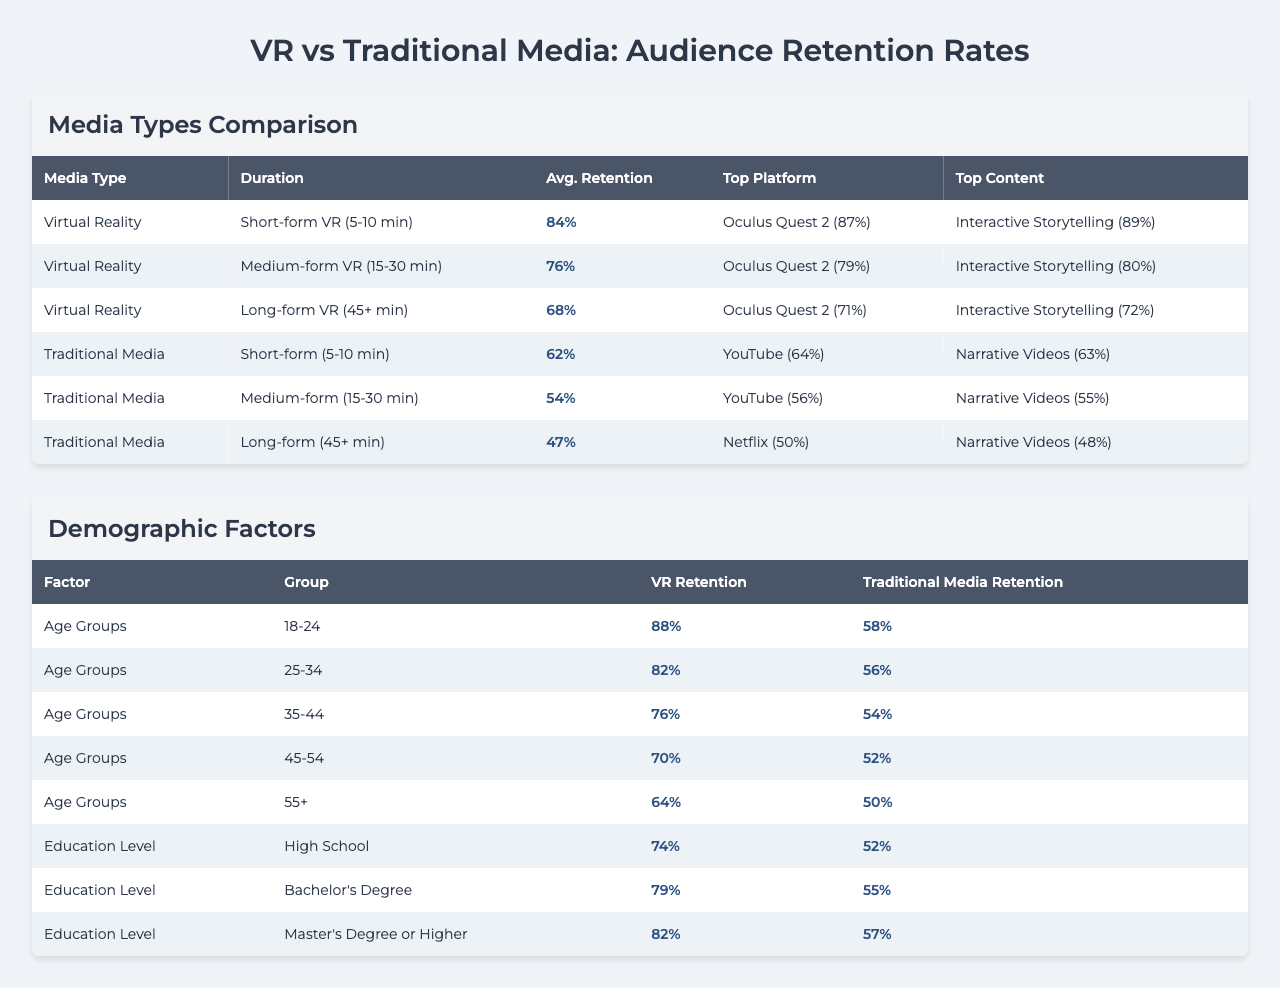What is the average retention rate for short-form VR experiences? From the table, the average retention rate for short-form VR (5-10 min) is listed as 84%.
Answer: 84% Which traditional media format has the highest average retention rate? The highest average retention rate in the traditional media formats is for short-form (5-10 min) at 62%.
Answer: 62% What percentage of the 18-24 age group retained VR experiences? The data shows that the retention rate for the 18-24 age group for VR is 88%.
Answer: 88% How does the VR retention rate for the 55+ age group compare to traditional media? The VR retention rate for the 55+ age group is 64%, while traditional media retention is 50%. This means VR is higher by 14 percentage points.
Answer: Yes, VR is higher by 14 percentage points What is the difference in average retention rates between short-form VR and short-form traditional media? The retention rate for short-form VR is 84% and for short-form traditional media it is 62%. The difference between them is 84% - 62% = 22%.
Answer: 22% Which platform had the highest retention rate for medium-form VR content? The top platform for medium-form VR (15-30 min) is Oculus Quest 2 with a retention rate of 79%.
Answer: Oculus Quest 2 What is the average retention rate for long-form traditional media? The average retention rate for long-form traditional media (45+ min) is 47% according to the table.
Answer: 47% Is the average retention rate for interactive storytelling in short-form VR higher than that in traditional media? In short-form VR, interactive storytelling has a retention rate of 89%, whereas the highest in short-form traditional media for narrative videos is 63%. Yes, it is higher by 26 percentage points.
Answer: Yes, by 26 percentage points What are the average retention rates for long-form VR and traditional media combined? The average for long-form VR is 68% and for long-form traditional media, it is 47%. The combined average is (68% + 47%) / 2 = 57.5%.
Answer: 57.5% Which content type had the lowest retention rate in medium-form VR? The content type with the lowest retention rate in medium-form VR is 360° Documentaries at 74%.
Answer: 74% How does the retention rate for medium-form VR compare to that of its equivalent in traditional media? The retention rate for medium-form VR is 76%, while for traditional media, it is 54%. Thus, medium-form VR retains more by 22 percentage points.
Answer: Yes, by 22 percentage points 